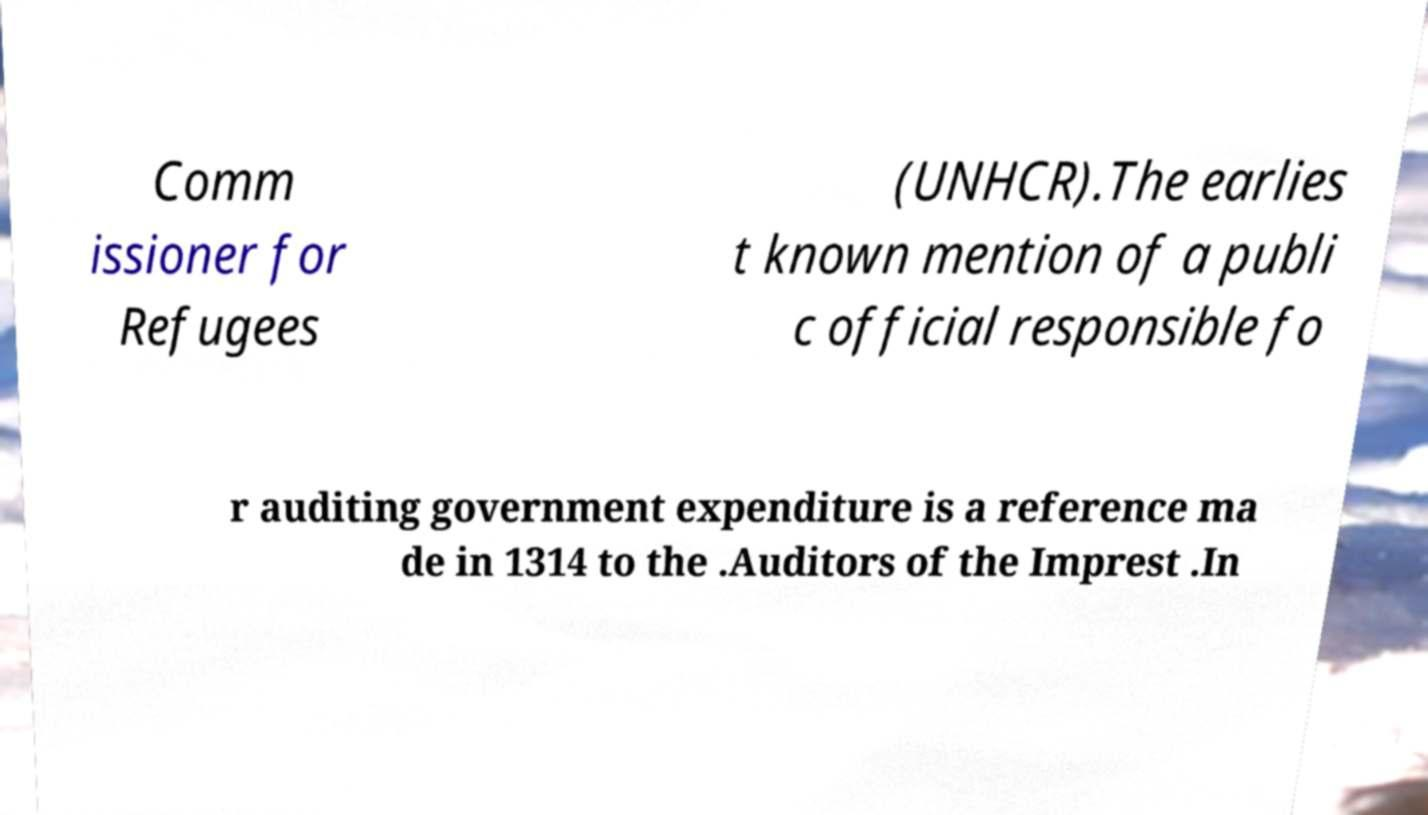Please read and relay the text visible in this image. What does it say? Comm issioner for Refugees (UNHCR).The earlies t known mention of a publi c official responsible fo r auditing government expenditure is a reference ma de in 1314 to the .Auditors of the Imprest .In 